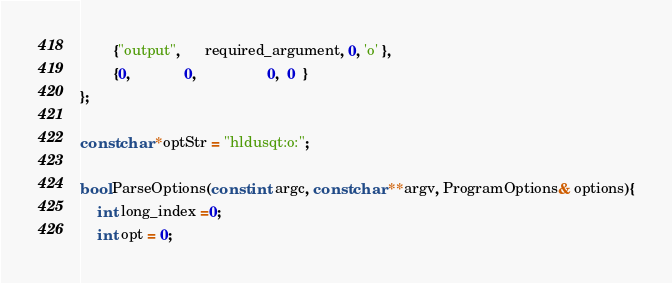<code> <loc_0><loc_0><loc_500><loc_500><_C_>        {"output",      required_argument, 0, 'o' },
        {0,             0,                 0,  0  }
};

const char *optStr = "hldusqt:o:";

bool ParseOptions(const int argc, const char **argv, ProgramOptions& options){
    int long_index =0;
    int opt = 0;</code> 